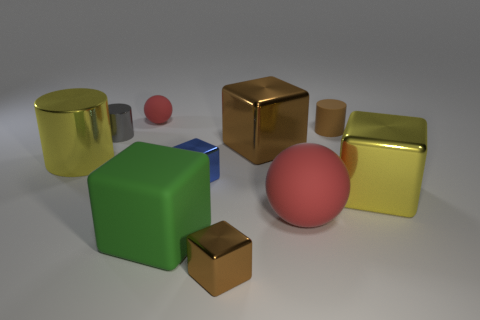How many red balls must be subtracted to get 1 red balls? 1 Subtract 1 blocks. How many blocks are left? 4 Subtract all cylinders. How many objects are left? 7 Add 2 large balls. How many large balls are left? 3 Add 7 large brown blocks. How many large brown blocks exist? 8 Subtract 0 brown balls. How many objects are left? 10 Subtract all brown metallic blocks. Subtract all red matte objects. How many objects are left? 6 